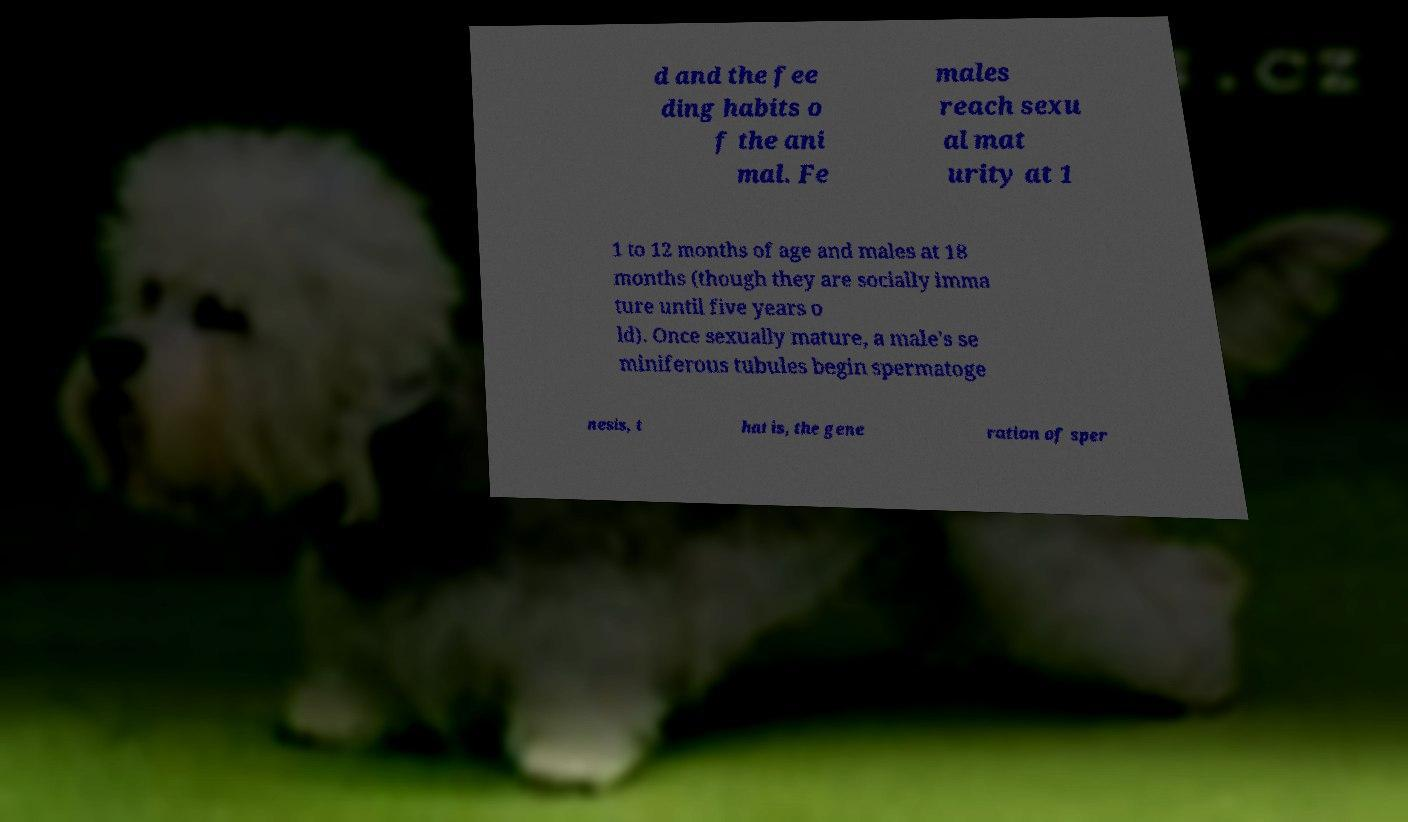Can you accurately transcribe the text from the provided image for me? d and the fee ding habits o f the ani mal. Fe males reach sexu al mat urity at 1 1 to 12 months of age and males at 18 months (though they are socially imma ture until five years o ld). Once sexually mature, a male's se miniferous tubules begin spermatoge nesis, t hat is, the gene ration of sper 